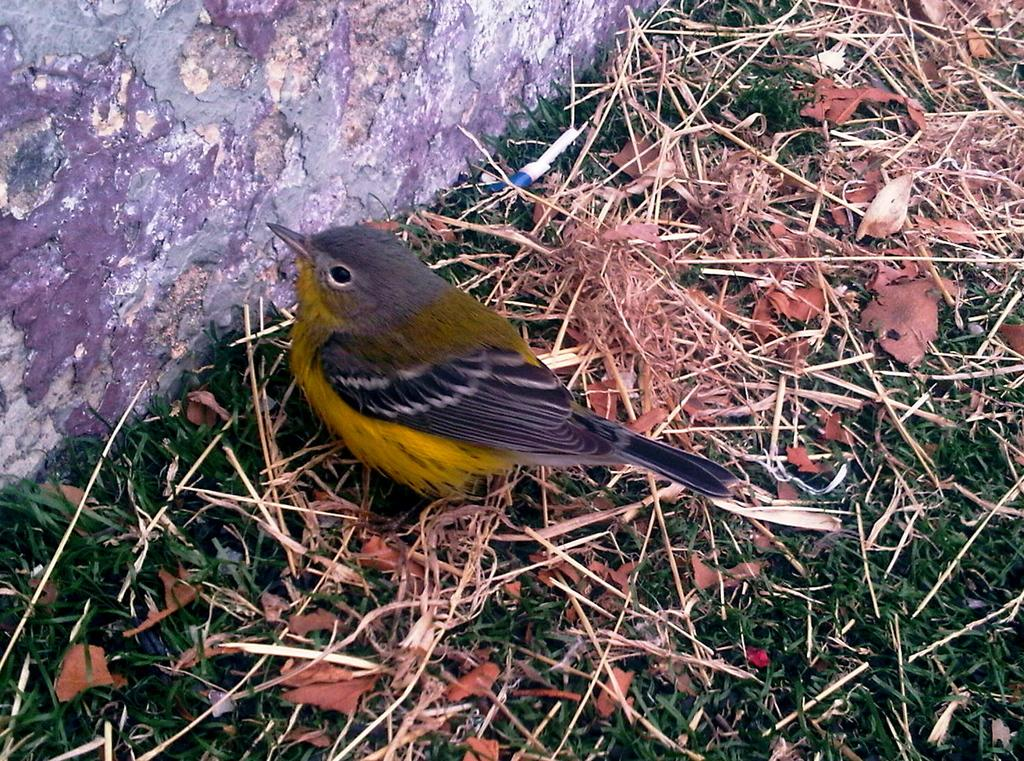What type of animal can be seen in the image? There is a bird in the image. Where is the bird located? The bird is standing on the grass. What is behind the bird in the image? The bird is in front of a wall. What is the condition of the grass in the image? There is dead grass in the image. What other natural elements can be seen in the image? There are leaves in the image. What type of bubble can be seen in the image? There is no bubble present in the image. Is there a band playing music in the image? There is no band present in the image. 